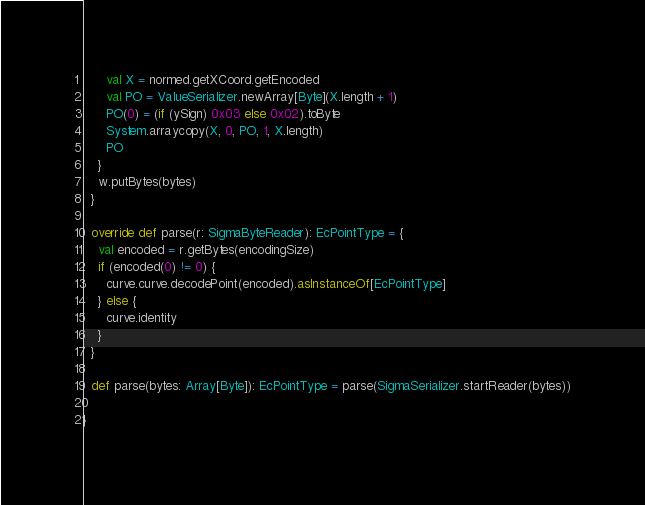<code> <loc_0><loc_0><loc_500><loc_500><_Scala_>      val X = normed.getXCoord.getEncoded
      val PO = ValueSerializer.newArray[Byte](X.length + 1)
      PO(0) = (if (ySign) 0x03 else 0x02).toByte
      System.arraycopy(X, 0, PO, 1, X.length)
      PO
    }
    w.putBytes(bytes)
  }

  override def parse(r: SigmaByteReader): EcPointType = {
    val encoded = r.getBytes(encodingSize)
    if (encoded(0) != 0) {
      curve.curve.decodePoint(encoded).asInstanceOf[EcPointType]
    } else {
      curve.identity
    }
  }

  def parse(bytes: Array[Byte]): EcPointType = parse(SigmaSerializer.startReader(bytes))

}
</code> 